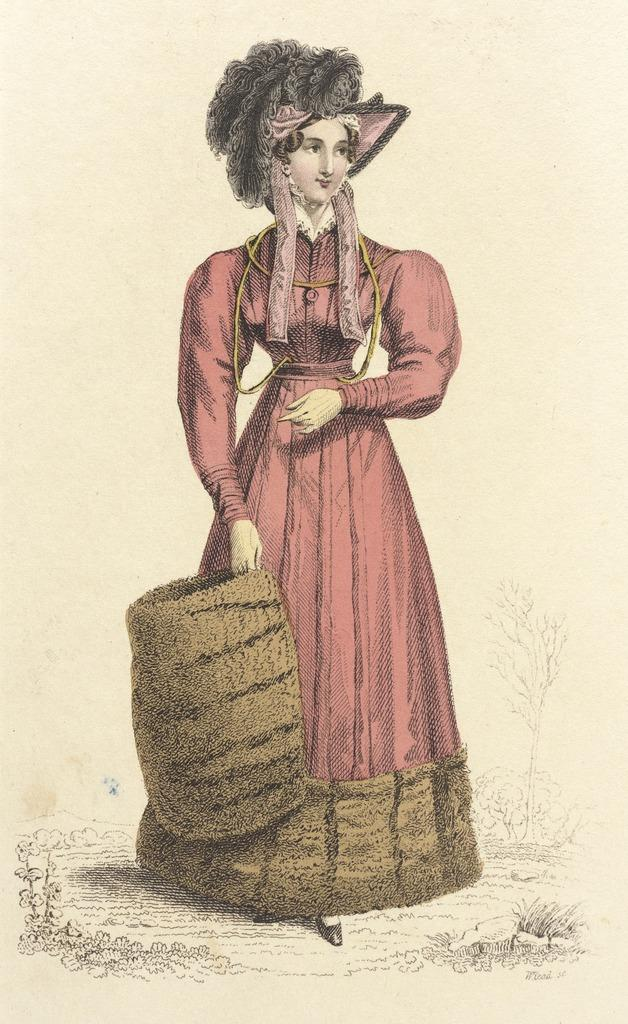Who is the main subject in the image? There is a woman in the image. What is the woman doing in the image? The woman is standing. What is the woman holding in the image? The woman is holding a brown color basket. What accessory is the woman wearing in the image? The woman is wearing a hat. What type of image is this? The image is a depiction. How many rabbits are sitting in the basket in the image? There are no rabbits present in the image; the woman is holding a brown color basket. What type of twig is the woman using to pick apples in the image? There is no twig or apple present in the image; the woman is holding a brown color basket. 